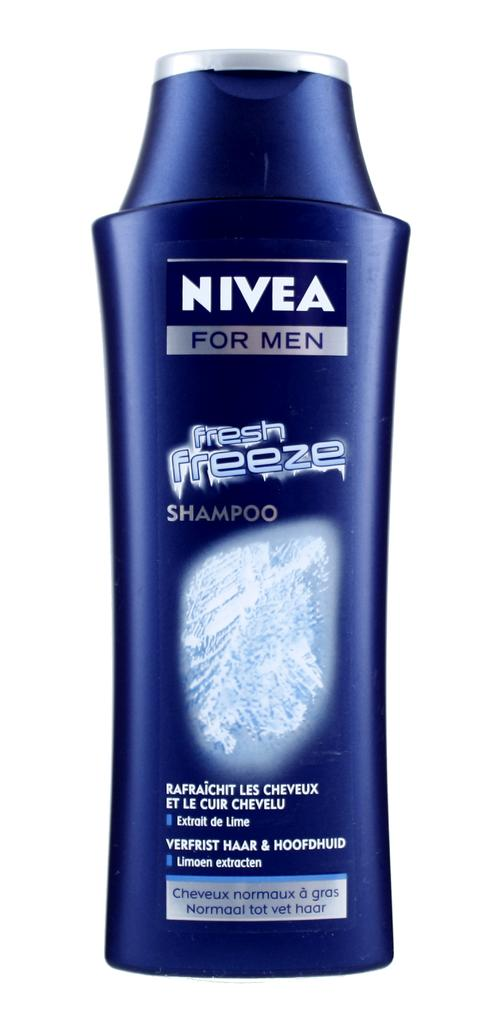What type of product is featured in the image? There is a Nivea shampoo bottle in the image. What color is the background of the image? The background of the image is white. How many tomatoes are on the hydrant in the image? There is no hydrant or tomatoes present in the image. What type of dinner is being prepared in the image? There is no dinner preparation or reference to food in the image. 